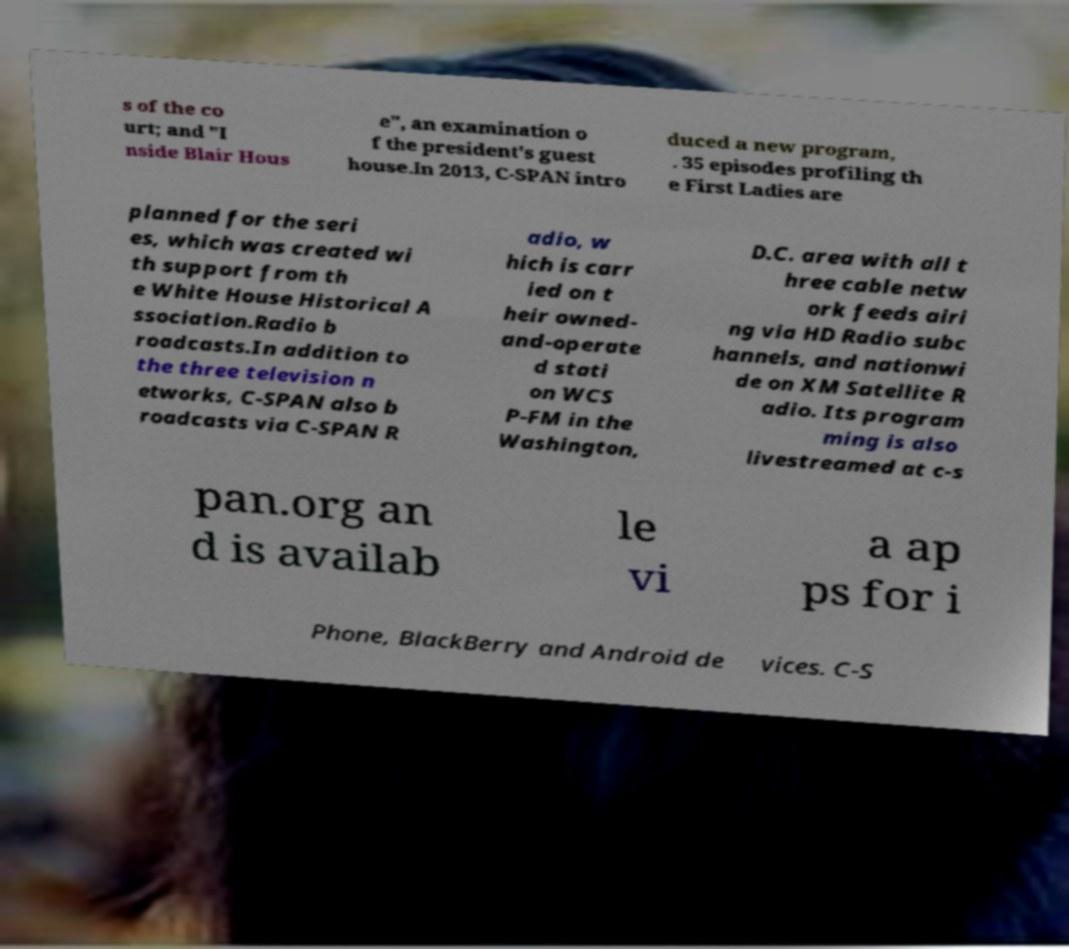Could you assist in decoding the text presented in this image and type it out clearly? s of the co urt; and "I nside Blair Hous e", an examination o f the president's guest house.In 2013, C-SPAN intro duced a new program, . 35 episodes profiling th e First Ladies are planned for the seri es, which was created wi th support from th e White House Historical A ssociation.Radio b roadcasts.In addition to the three television n etworks, C-SPAN also b roadcasts via C-SPAN R adio, w hich is carr ied on t heir owned- and-operate d stati on WCS P-FM in the Washington, D.C. area with all t hree cable netw ork feeds airi ng via HD Radio subc hannels, and nationwi de on XM Satellite R adio. Its program ming is also livestreamed at c-s pan.org an d is availab le vi a ap ps for i Phone, BlackBerry and Android de vices. C-S 